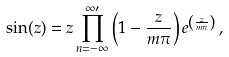<formula> <loc_0><loc_0><loc_500><loc_500>\sin ( z ) = z \prod _ { n = - \infty } ^ { \infty \prime } \left ( 1 - \frac { z } { m \pi } \right ) e ^ { \left ( \frac { z } { m \pi } \right ) } \, ,</formula> 